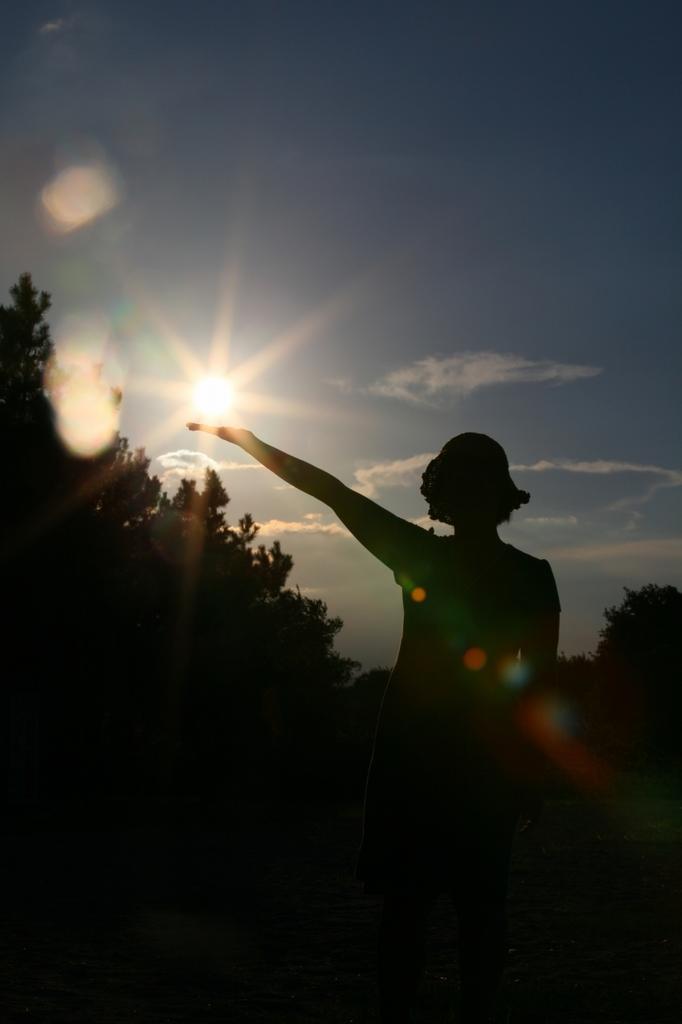Please provide a concise description of this image. In this image there is a woman standing, in the background there are trees and there is a sun in the sky. 